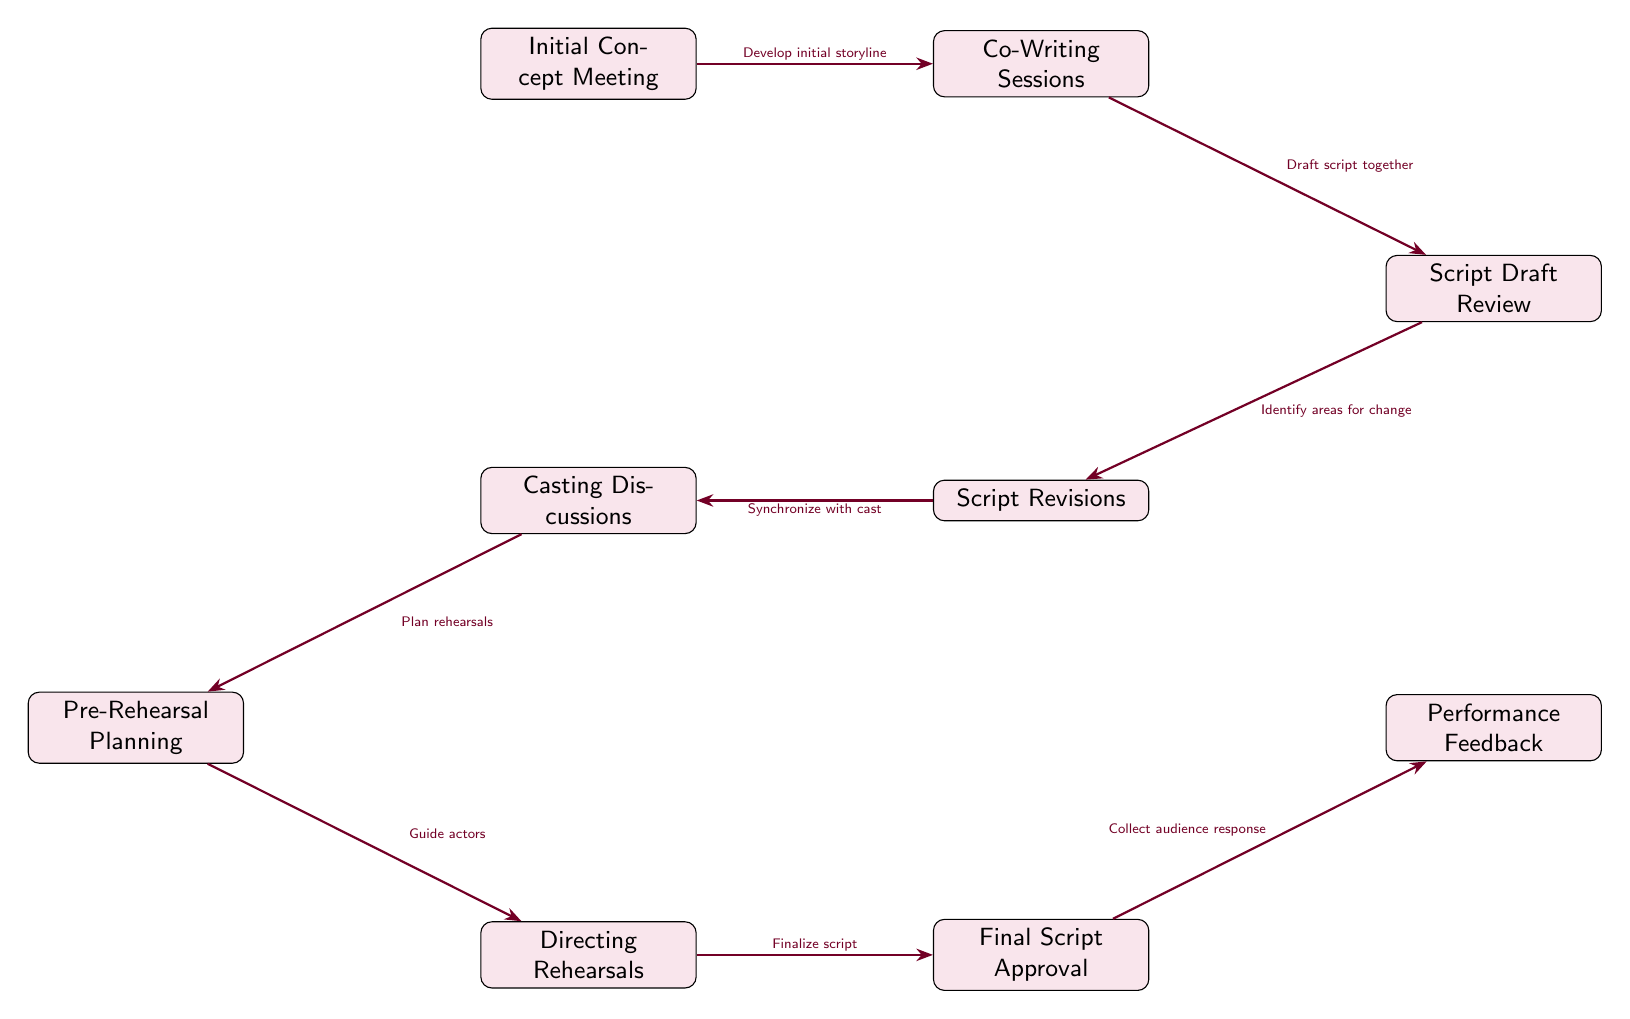What is the first step in the collaborative process? The first node in the diagram is 'Initial Concept Meeting', indicating that this is the starting point of the collaborative process.
Answer: Initial Concept Meeting How many key stages are shown in the diagram? There are a total of nine nodes, each representing a key stage in the collaborative process between the playwright and director.
Answer: Nine What stage comes after 'Co-Writing Sessions'? Looking at the arrows from 'Co-Writing Sessions', the next node is 'Script Draft Review', indicating that this is the following stage in the process.
Answer: Script Draft Review What do the arrows represent in the diagram? The arrows between the nodes symbolize the flow of the collaborative process, indicating the progression from one stage to the next and the relationships between these stages.
Answer: Flow of process What is the final output of the collaborative process? The last node, 'Performance Feedback', signifies that the ultimate outcome of this collaborative process is the audience response collected after the performance.
Answer: Performance Feedback Which stage focuses on gathering input from the cast? The 'Script Revisions' stage connects to 'Casting Discussions', highlighting that this is where input and synchronization with the cast occur to refine the script.
Answer: Casting Discussions Explain the path from 'Script Draft Review' to 'Final Script Approval'. Starting from 'Script Draft Review', this leads to 'Script Revisions', which then connects to 'Final Script Approval'; this shows that revisions based on the review are required before final approval.
Answer: Script Revisions How do ‘Directing Rehearsals’ relate to the final approvals? 'Directing Rehearsals' directly leads to 'Final Script Approval'; this indicates that rehearsals contribute to the finalization of the script based on performance aspects observed during the rehearsals.
Answer: Directly related What process follows 'Pre-Rehearsal Planning'? Following 'Pre-Rehearsal Planning', the next stage illustrated is 'Directing Rehearsals', showing that planning leads directly into the rehearsal phase.
Answer: Directing Rehearsals 